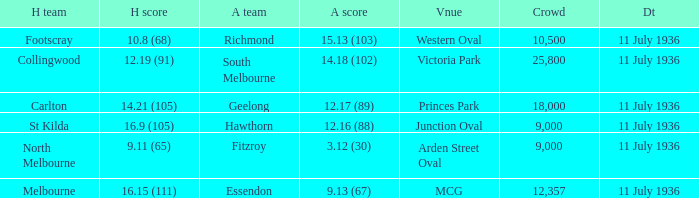When was the game with richmond as Away team? 11 July 1936. 